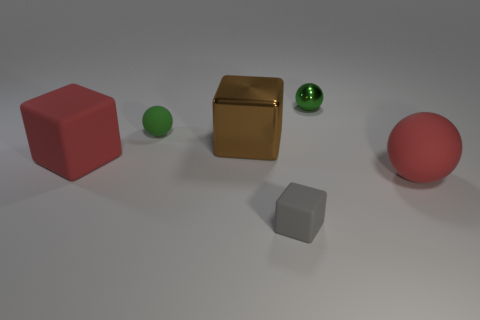Can you describe the positioning and colors of the blocks relative to the spheres? Certainly, in the image, there are three blocks and three spheres. To the far left is a red cube. A brown metallic block is centered amongst all objects, and a gray cube is off to its right. The spheres are composed of a small green one to the left of the brown block, a large red one to the right, and another larger shiny green sphere to the far right.  If I wanted to create a symmetrical arrangement with the objects in this image, what changes would be necessary? To achieve symmetry, you would need to reposition the objects. For instance, you could place a sphere at each end with identical blocks in between, aligning the objects along a central axis. As it stands, the gray cube would need to be swapped with the red sphere to mirror the left side, assuming the brown block as the center. You would also need another red cube to mirror the red cube on the left side. 